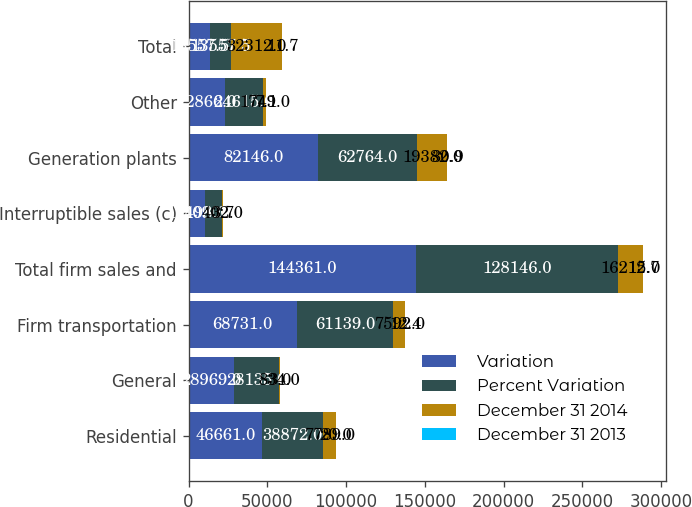<chart> <loc_0><loc_0><loc_500><loc_500><stacked_bar_chart><ecel><fcel>Residential<fcel>General<fcel>Firm transportation<fcel>Total firm sales and<fcel>Interruptible sales (c)<fcel>Generation plants<fcel>Other<fcel>Total<nl><fcel>Variation<fcel>46661<fcel>28969<fcel>68731<fcel>144361<fcel>10498<fcel>82146<fcel>22866<fcel>13557.5<nl><fcel>Percent Variation<fcel>38872<fcel>28135<fcel>61139<fcel>128146<fcel>10900<fcel>62764<fcel>24615<fcel>13557.5<nl><fcel>December 31 2014<fcel>7789<fcel>834<fcel>7592<fcel>16215<fcel>402<fcel>19382<fcel>1749<fcel>32312<nl><fcel>December 31 2013<fcel>20<fcel>3<fcel>12.4<fcel>12.7<fcel>3.7<fcel>30.9<fcel>7.1<fcel>11.7<nl></chart> 